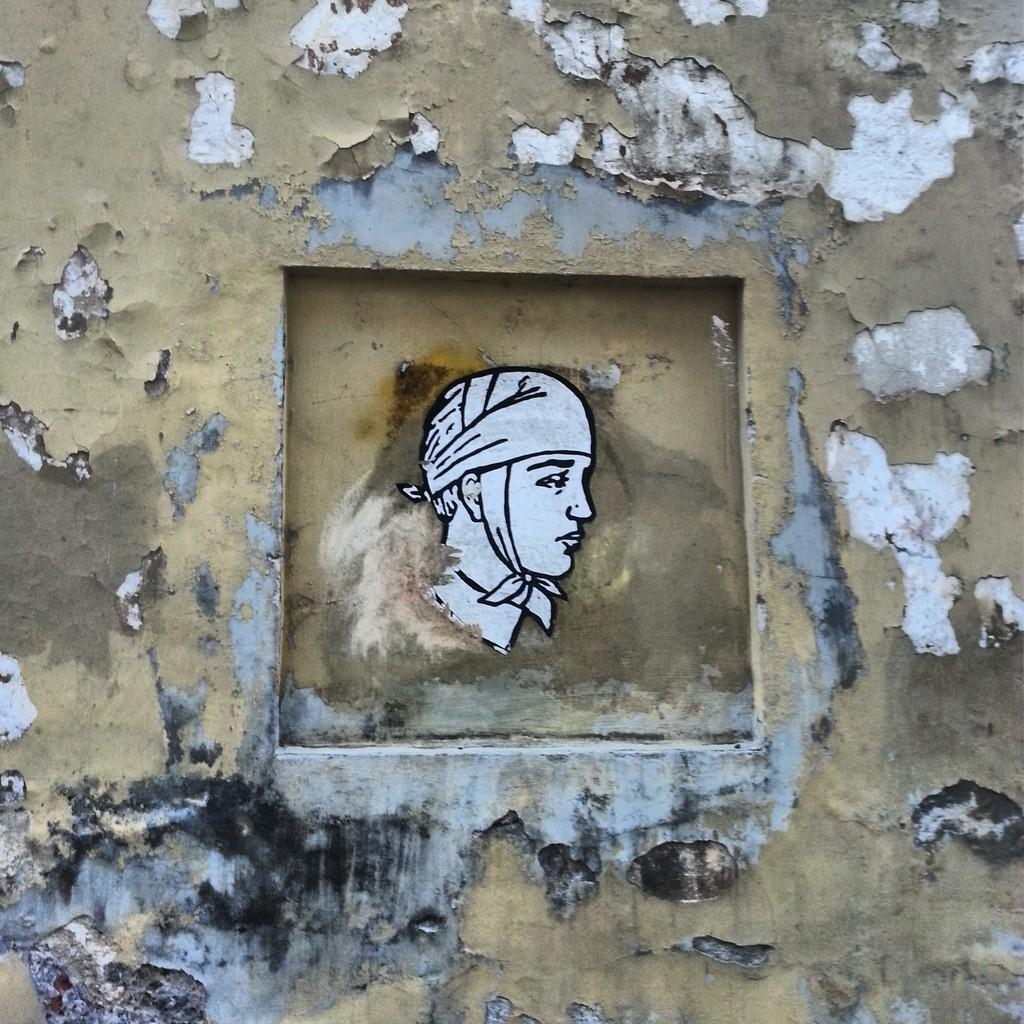What is the main subject of the image? The main subject of the image is a person's face. How is the person's face displayed in the image? The person's face is attached to a wall. What colors can be seen on the wall in the image? The wall has a cream and white color. What type of spark can be seen coming from the person's face in the image? There is no spark present in the image; it only features a person's face attached to a wall with a cream and white color. 